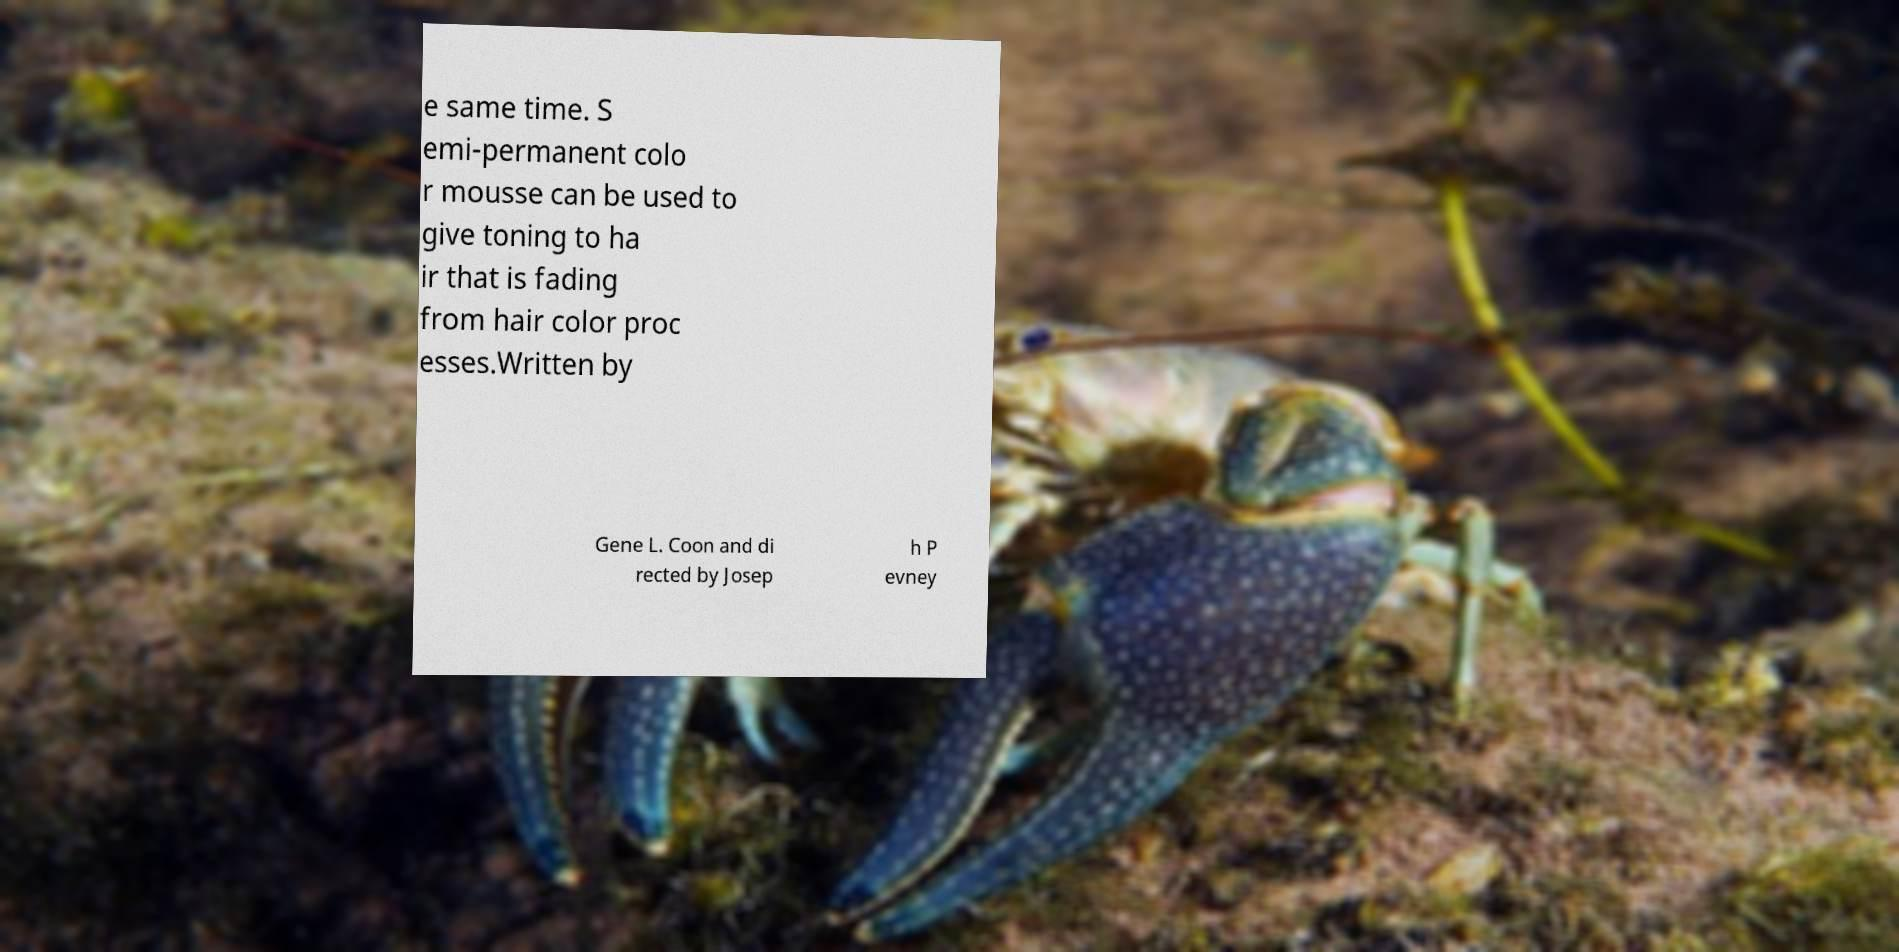I need the written content from this picture converted into text. Can you do that? e same time. S emi-permanent colo r mousse can be used to give toning to ha ir that is fading from hair color proc esses.Written by Gene L. Coon and di rected by Josep h P evney 